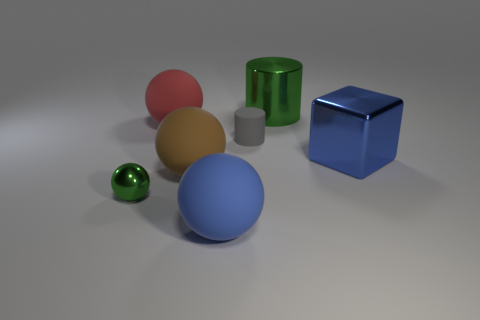What number of other objects are there of the same size as the red matte ball?
Offer a terse response. 4. What color is the cylinder that is to the right of the gray rubber object?
Keep it short and to the point. Green. Is the ball in front of the tiny ball made of the same material as the big brown thing?
Keep it short and to the point. Yes. How many objects are in front of the brown rubber object and to the right of the large red object?
Offer a very short reply. 1. What color is the shiny thing in front of the blue object on the right side of the green metallic thing that is to the right of the big blue matte ball?
Offer a very short reply. Green. How many other objects are there of the same shape as the large red rubber thing?
Your answer should be very brief. 3. There is a large thing in front of the shiny ball; is there a big thing that is right of it?
Your answer should be compact. Yes. How many metallic things are big cubes or tiny green things?
Give a very brief answer. 2. What is the material of the large object that is on the right side of the small gray rubber thing and to the left of the large blue metal block?
Keep it short and to the point. Metal. Is there a big red object left of the shiny object on the right side of the green object that is right of the big brown ball?
Keep it short and to the point. Yes. 